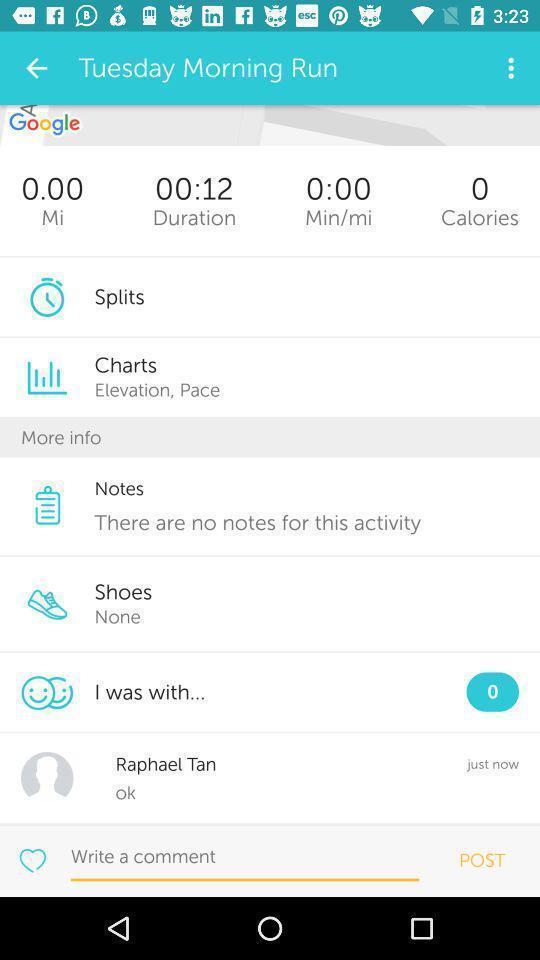Explain the elements present in this screenshot. Screen showing tuesday morning run. 